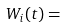<formula> <loc_0><loc_0><loc_500><loc_500>W _ { i } ( t ) =</formula> 